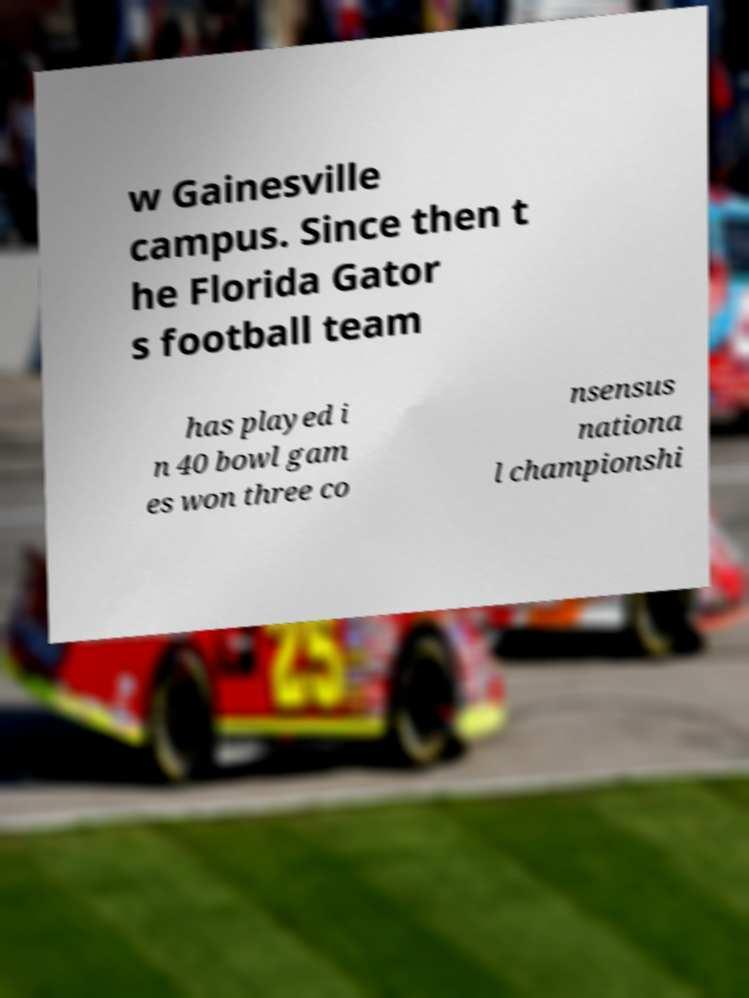What messages or text are displayed in this image? I need them in a readable, typed format. w Gainesville campus. Since then t he Florida Gator s football team has played i n 40 bowl gam es won three co nsensus nationa l championshi 